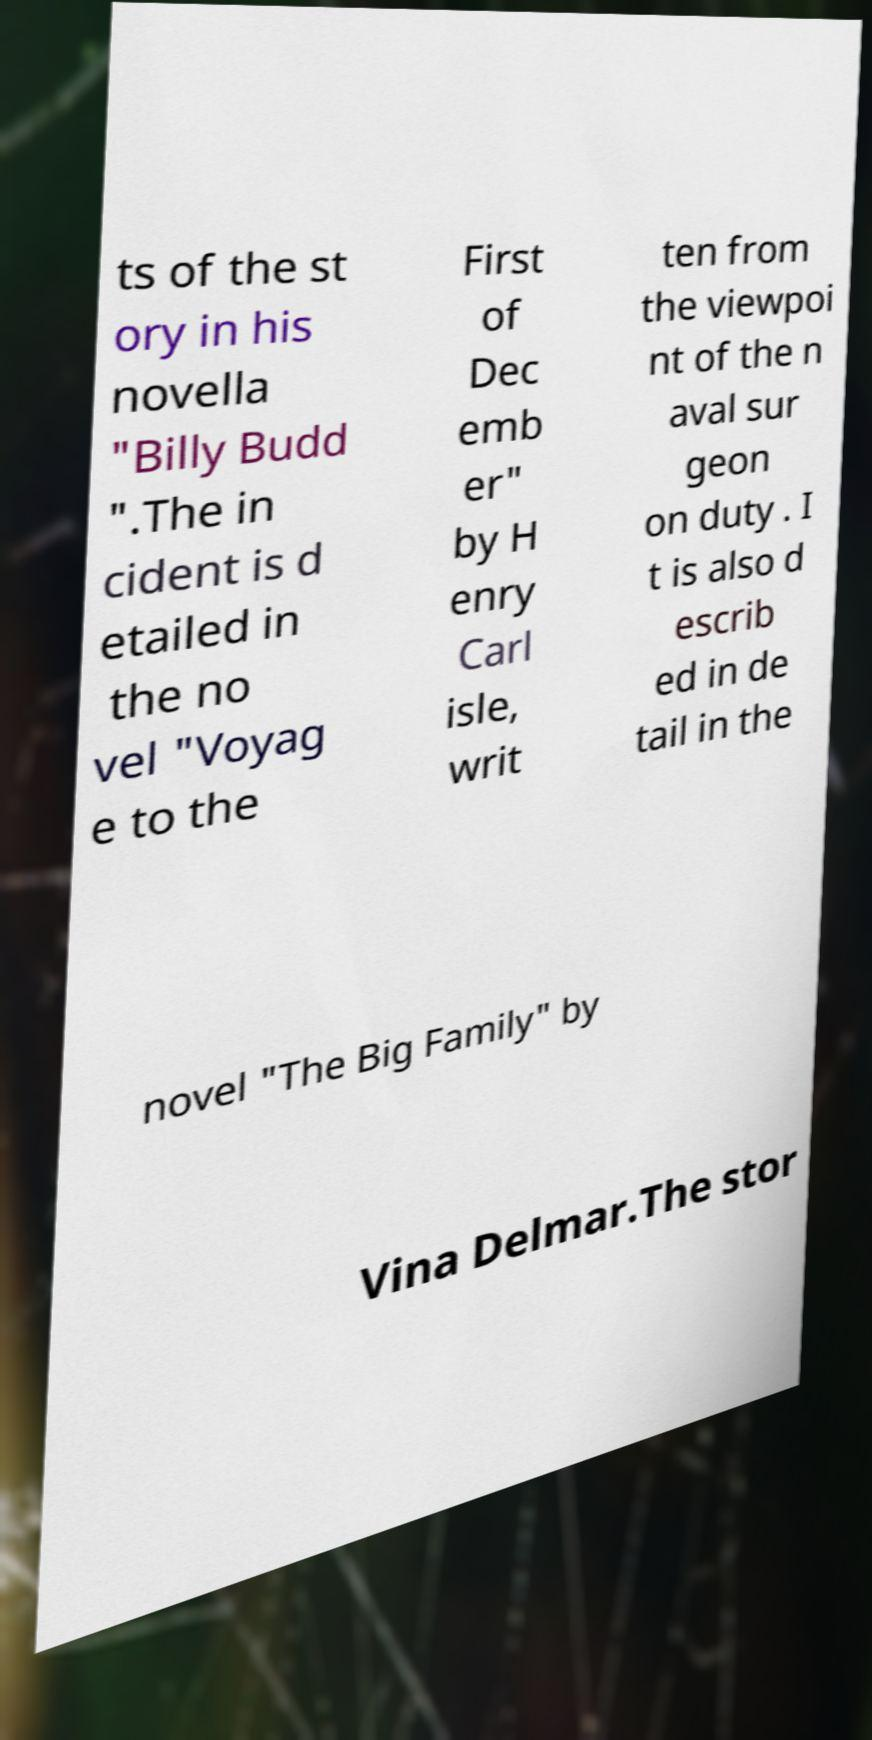Could you extract and type out the text from this image? ts of the st ory in his novella "Billy Budd ".The in cident is d etailed in the no vel "Voyag e to the First of Dec emb er" by H enry Carl isle, writ ten from the viewpoi nt of the n aval sur geon on duty . I t is also d escrib ed in de tail in the novel "The Big Family" by Vina Delmar.The stor 